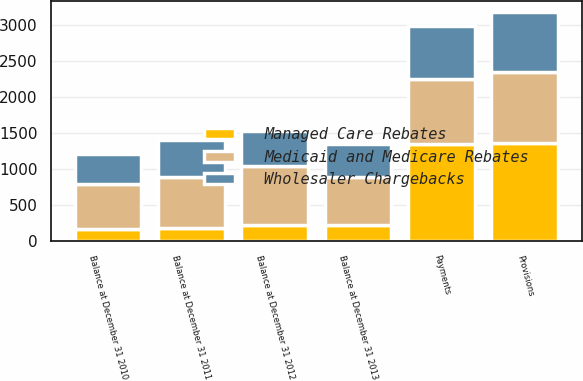Convert chart. <chart><loc_0><loc_0><loc_500><loc_500><stacked_bar_chart><ecel><fcel>Balance at December 31 2010<fcel>Provisions<fcel>Payments<fcel>Balance at December 31 2011<fcel>Balance at December 31 2012<fcel>Balance at December 31 2013<nl><fcel>Medicaid and Medicare Rebates<fcel>634<fcel>985<fcel>899<fcel>720<fcel>807<fcel>667<nl><fcel>Wholesaler Chargebacks<fcel>410<fcel>831<fcel>735<fcel>506<fcel>496<fcel>459<nl><fcel>Managed Care Rebates<fcel>159<fcel>1361<fcel>1349<fcel>171<fcel>224<fcel>212<nl></chart> 